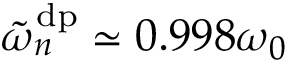<formula> <loc_0><loc_0><loc_500><loc_500>\tilde { \omega } _ { n } ^ { d p } \simeq 0 . 9 9 8 \omega _ { 0 }</formula> 